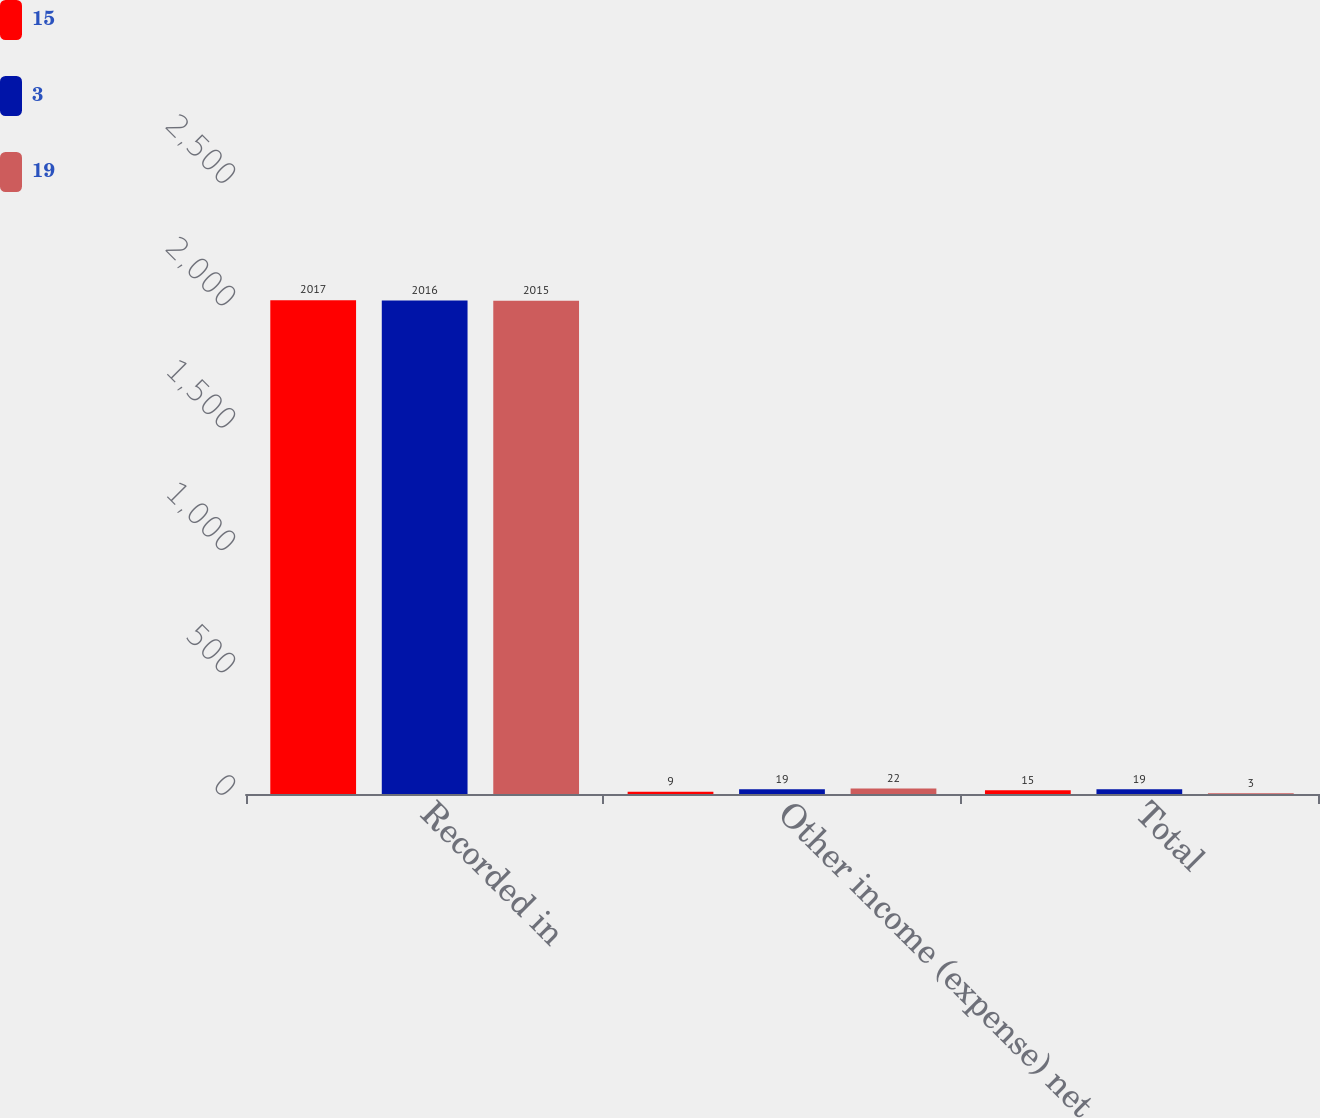Convert chart. <chart><loc_0><loc_0><loc_500><loc_500><stacked_bar_chart><ecel><fcel>Recorded in<fcel>Other income (expense) net<fcel>Total<nl><fcel>15<fcel>2017<fcel>9<fcel>15<nl><fcel>3<fcel>2016<fcel>19<fcel>19<nl><fcel>19<fcel>2015<fcel>22<fcel>3<nl></chart> 